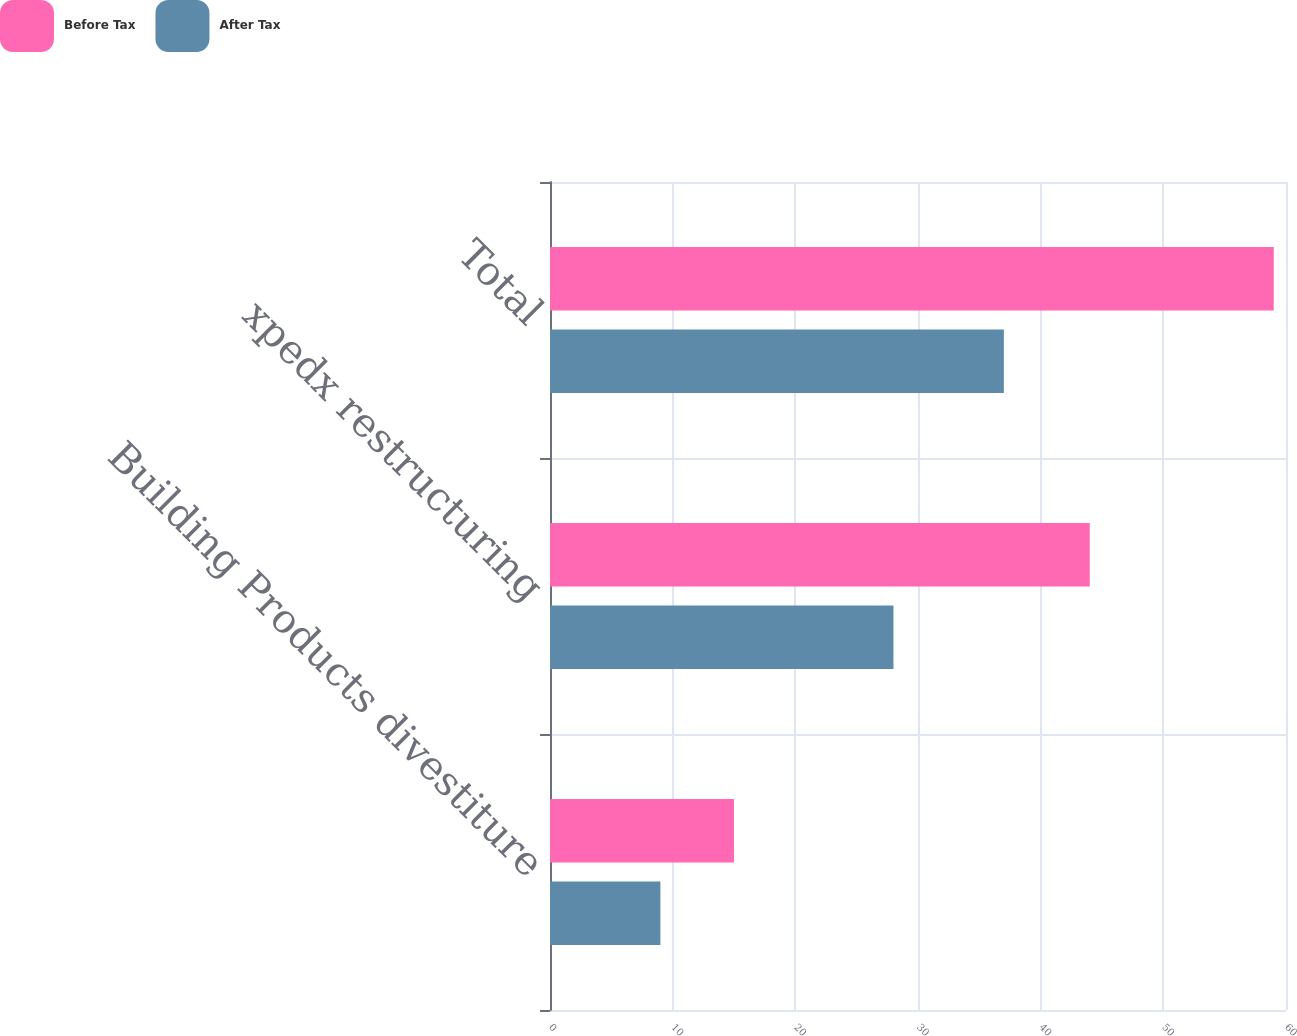<chart> <loc_0><loc_0><loc_500><loc_500><stacked_bar_chart><ecel><fcel>Building Products divestiture<fcel>xpedx restructuring<fcel>Total<nl><fcel>Before Tax<fcel>15<fcel>44<fcel>59<nl><fcel>After Tax<fcel>9<fcel>28<fcel>37<nl></chart> 